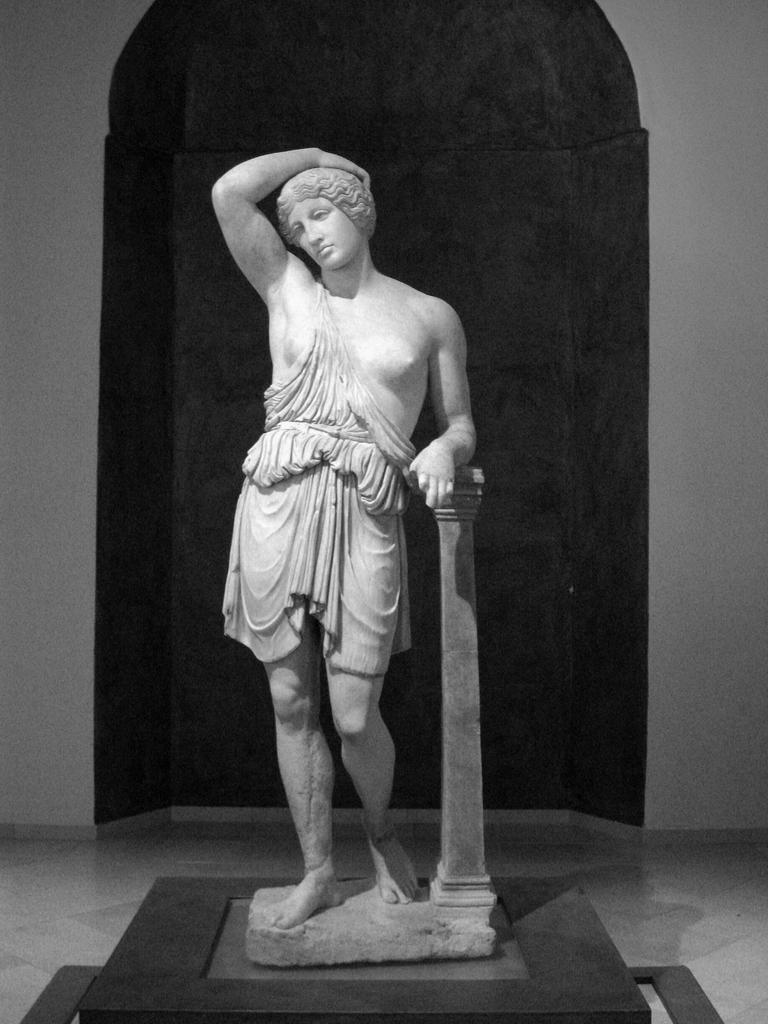What is the main subject in the center of the image? There is a statue in the center of the image. What can be seen in the background of the image? There is a wall in the background of the image. What type of body is visible in the jar on the statue's head? There is no jar or body present on the statue's head in the image. How many pigs are sitting on the statue's shoulders? There are no pigs present on the statue's shoulders in the image. 